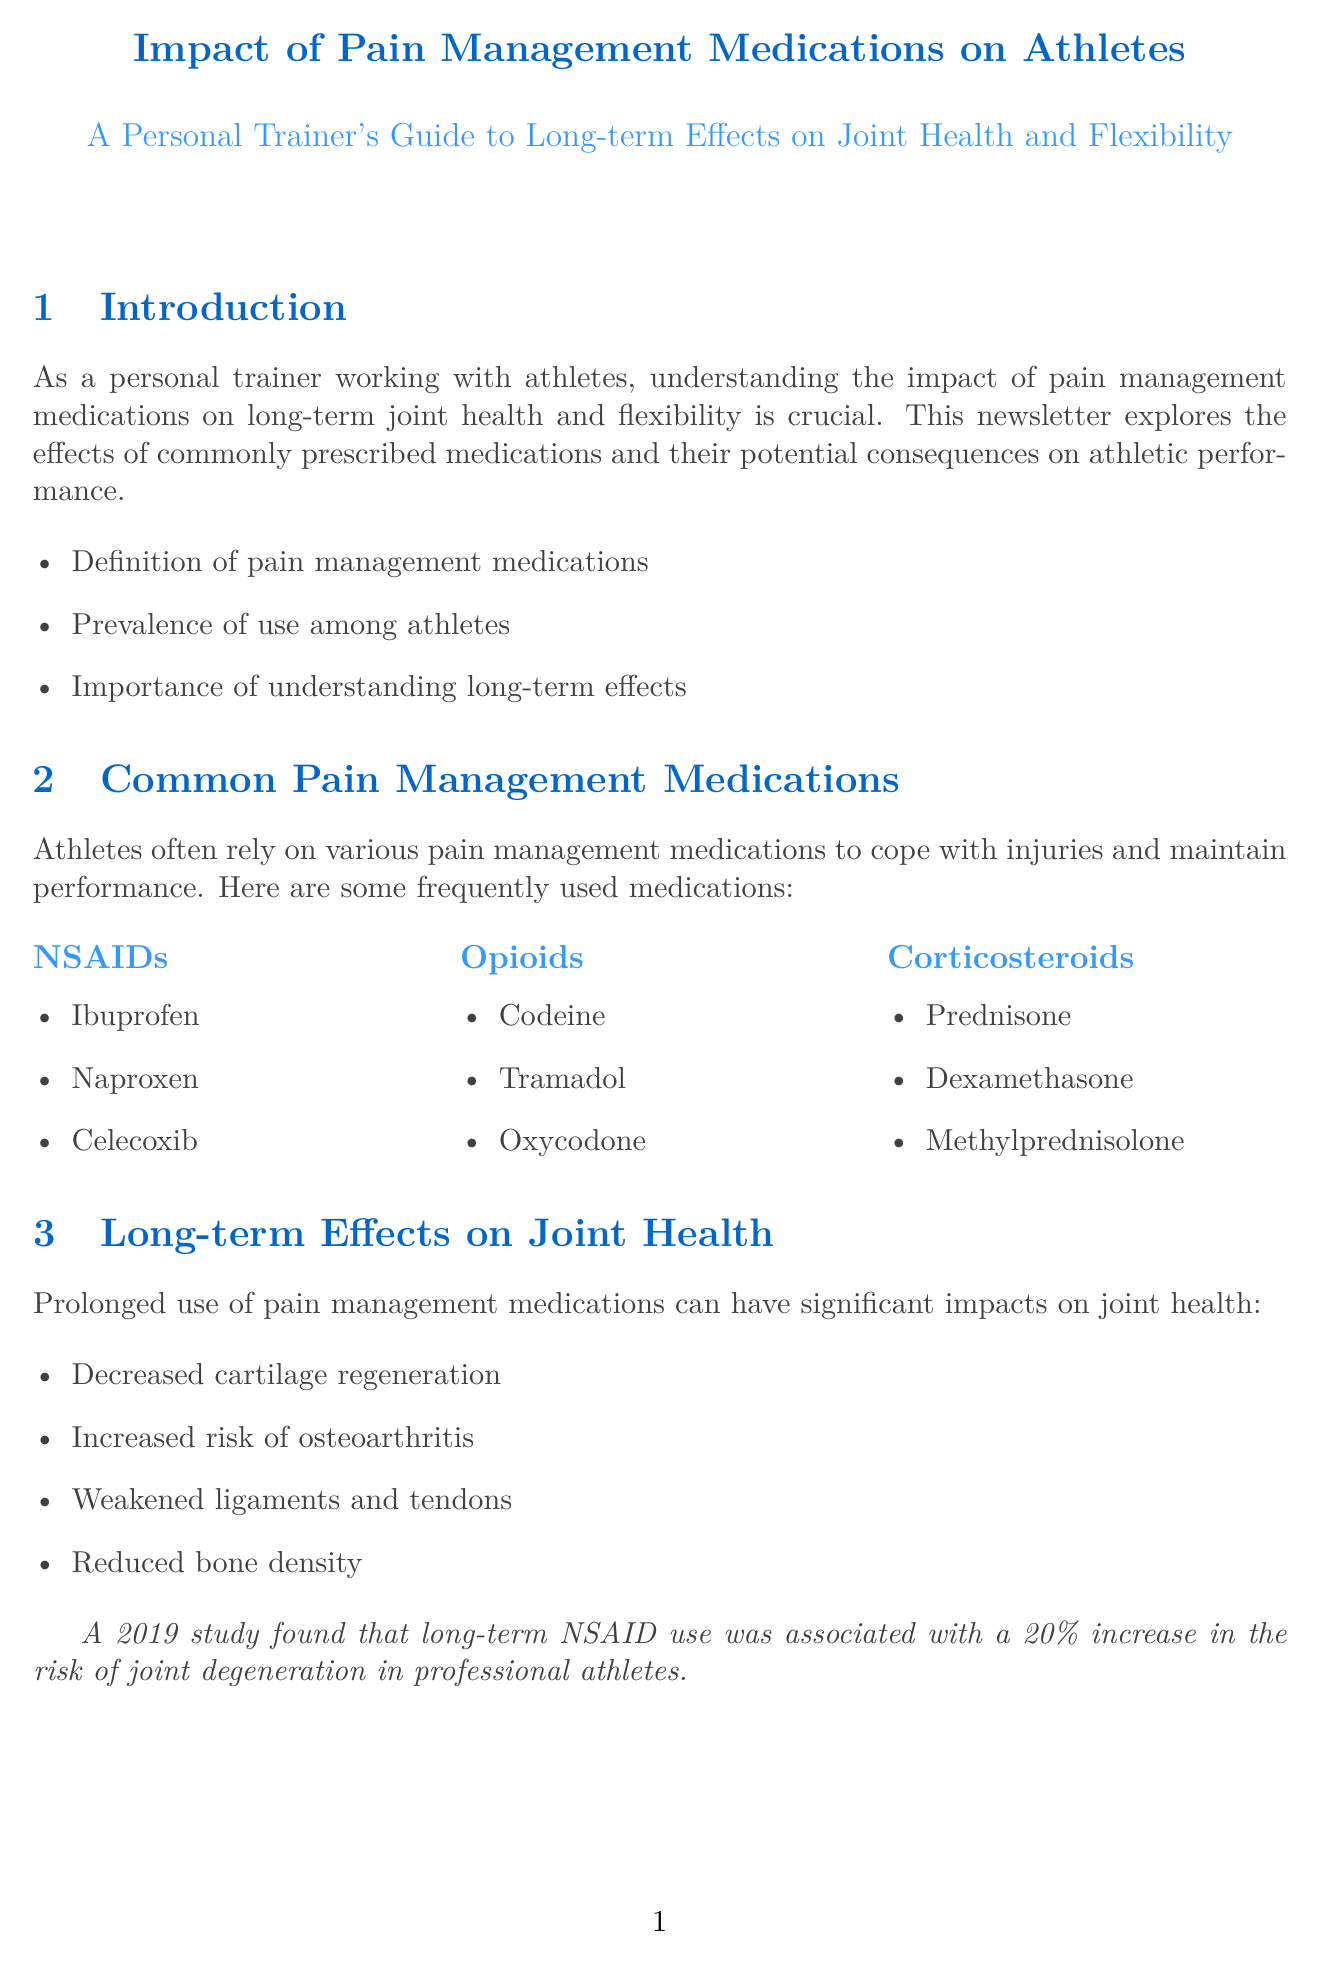What is the definition of pain management medications? The document states that pain management medications are used to cope with injuries and maintain performance among athletes.
Answer: Pain management medications What are the examples of NSAIDs mentioned in the newsletter? The newsletter lists Ibuprofen, Naproxen, and Celecoxib as examples of NSAIDs used by athletes.
Answer: Ibuprofen, Naproxen, Celecoxib What long-term effect of pain management medications increases the risk of osteoarthritis? The document indicates that prolonged use can lead to an increased risk of osteoarthritis.
Answer: Increased risk of osteoarthritis Which expert is quoted regarding pain medications and flexibility? The document cites Dr. James Andrews as an expert on the matter of pain medications and flexibility.
Answer: Dr. James Andrews What alternative approach to pain management involves nutrition? The newsletter suggests incorporating nutrition and supplementation for joint health as an alternative approach.
Answer: Nutrition and supplementation for joint health According to the document, what percentage increase in joint degeneration risk is associated with long-term NSAID use? The document references a study stating that long-term NSAID use is linked to a 20% increase in joint degeneration risk.
Answer: 20% What is the purpose of corticosteroids listed in the document? The newsletter states that corticosteroids are used to reduce inflammation in joints and soft tissues.
Answer: Reduce inflammation in joints and soft tissues How should athletes use pain medications according to the recommendations? The document recommends that pain medications be used judiciously and for short durations.
Answer: Judiciously and for short durations 